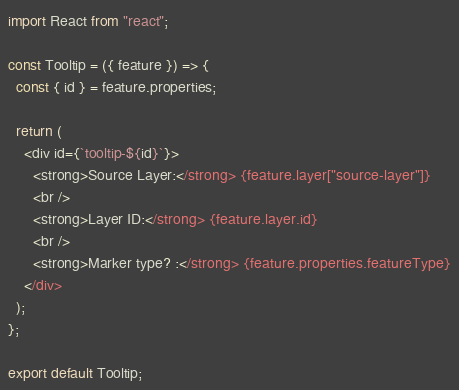<code> <loc_0><loc_0><loc_500><loc_500><_JavaScript_>import React from "react";

const Tooltip = ({ feature }) => {
  const { id } = feature.properties;
  
  return (
    <div id={`tooltip-${id}`}>
      <strong>Source Layer:</strong> {feature.layer["source-layer"]}
      <br />
      <strong>Layer ID:</strong> {feature.layer.id}
      <br />
      <strong>Marker type? :</strong> {feature.properties.featureType}
    </div>
  );
};

export default Tooltip;
</code> 